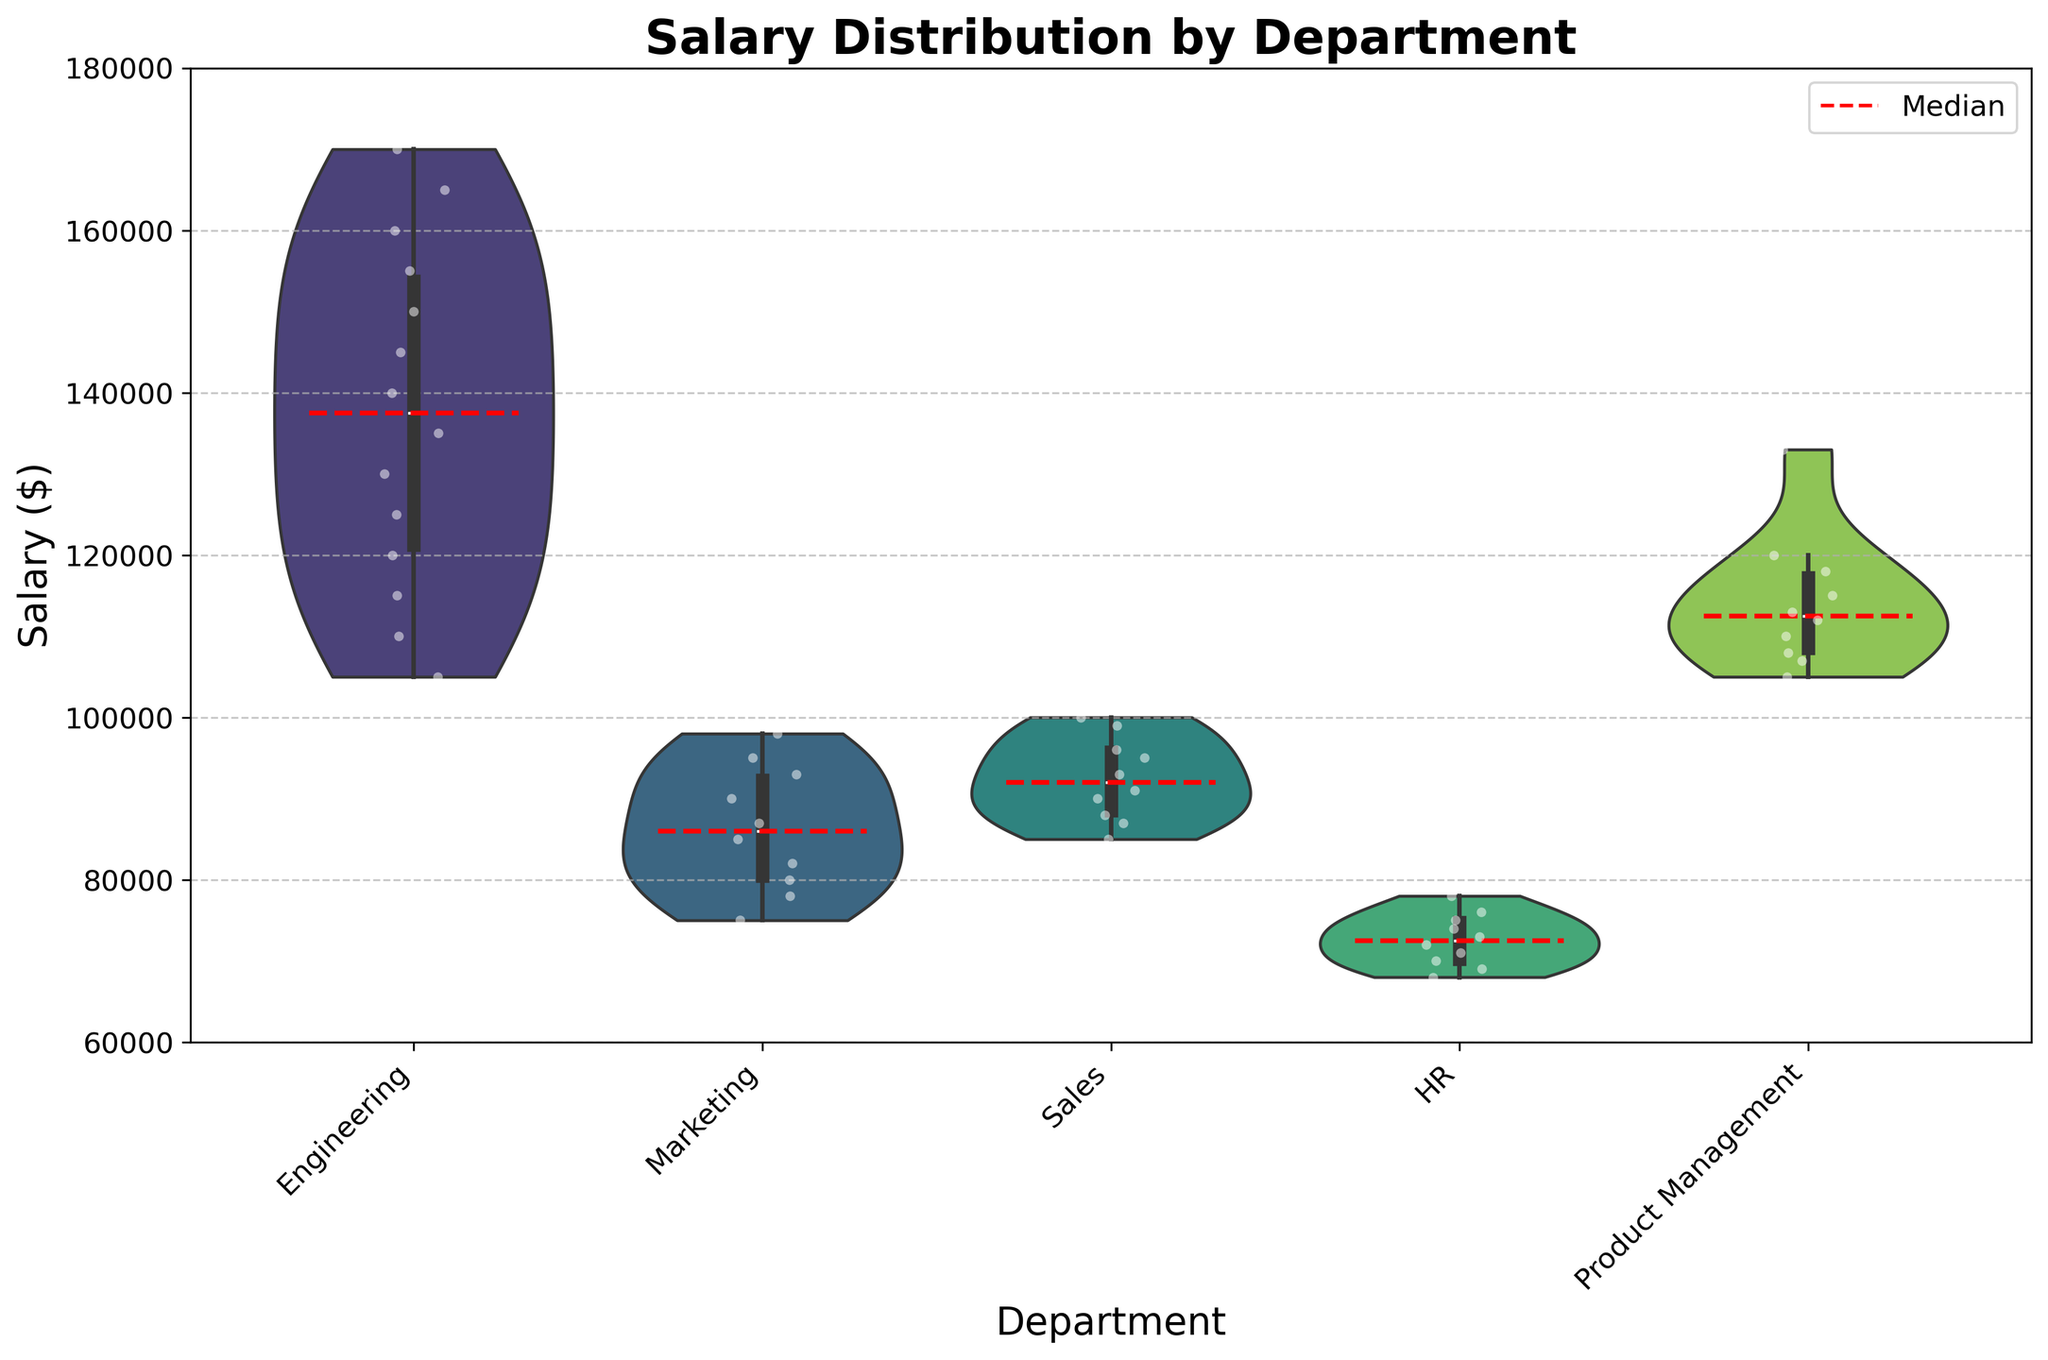What's the title of the figure? The title is shown at the top of the figure, usually in bold and larger font than the rest of the text.
Answer: Salary Distribution by Department Which department has the highest median salary? The highest median salary can be identified by locating the red dashed median line across the violin shapes. The "Engineering" department has the highest position of this line.
Answer: Engineering What is the approximate salary range for the Marketing department? By observing the vertical span of the violin plot for the Marketing department, we can estimate that the salary range is roughly from $75,000 to $98,000.
Answer: $75,000 to $98,000 Which two departments have the most similar salary ranges? By comparing the height of the violin plots for each department, the "Sales" and "Marketing" departments have similar salary ranges, both spanning approximately from $75,000 to $98,000 and $85,000 to $99,000 respectively.
Answer: Sales and Marketing What is the lowest salary recorded in the data, and which department does it belong to? The lowest salary can be found by looking at the lowest point of the jittered points or the bottom tail of the violins. This value is $68,000, which belongs to the HR department.
Answer: $68,000, HR Which department’s median salary is closest to $100,000? By examining the red dashed median lines and their proximity to $100,000 on the y-axis, the median salary for the Product Management department is closest to $100,000.
Answer: Product Management How many departments are represented in the figure? The number of departments can be counted by looking at the x-axis labels. There are five department labels present in the figure.
Answer: Five Is there a department where the salaries span below $70,000? If so, which one? By checking the lower limits of the violin plots, we see that the HR department's salary range extends below $70,000.
Answer: HR Which department has the widest salary distribution? The department with the tallest and thus the widest violin plot represents the widest salary distribution. The Engineering department shows the widest distribution ranging from approximately $105,000 to $170,000.
Answer: Engineering What color are the jittered points, and why might this choice be effective? The jittered points are white with black edges. This color choice effectively contrasts with the colored violins, making the individual salaries distinct and easy to observe.
Answer: White with black edges 